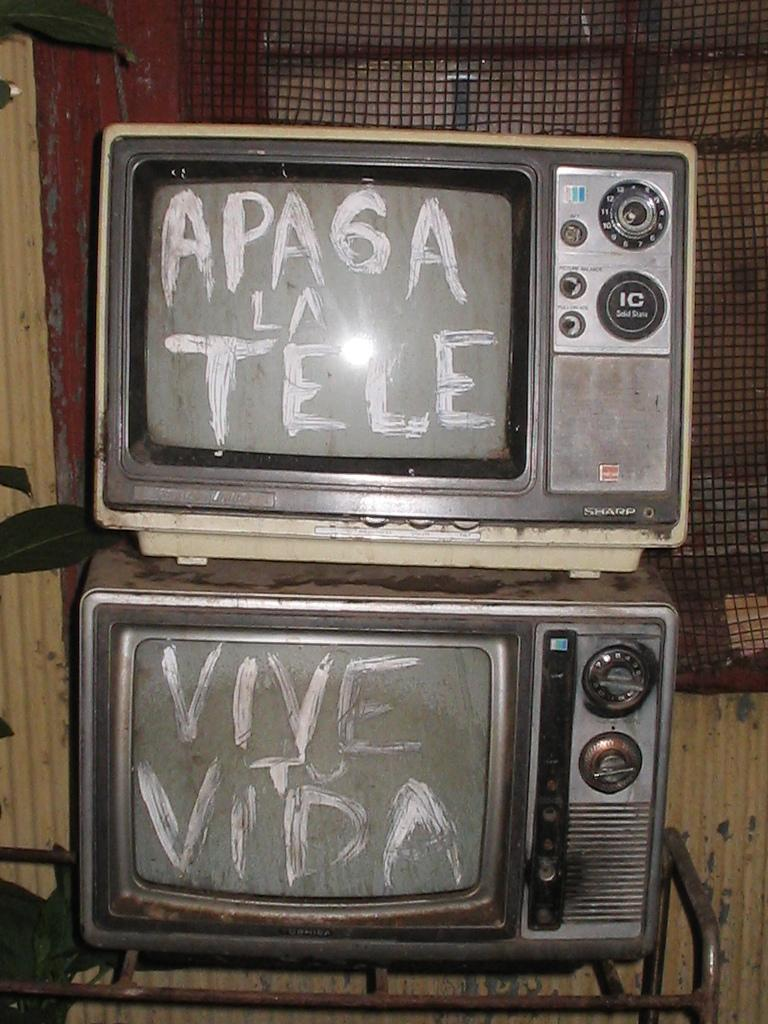<image>
Provide a brief description of the given image. Two old fashioned TVs have white paint that says Vive To Vida and Apa6a La Tele. 